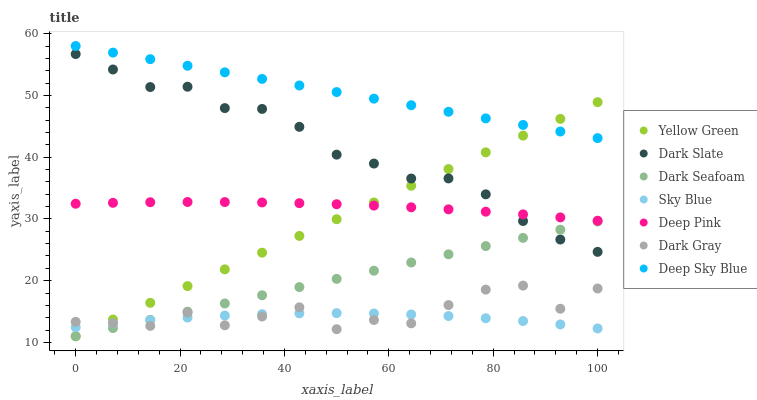Does Sky Blue have the minimum area under the curve?
Answer yes or no. Yes. Does Deep Sky Blue have the maximum area under the curve?
Answer yes or no. Yes. Does Yellow Green have the minimum area under the curve?
Answer yes or no. No. Does Yellow Green have the maximum area under the curve?
Answer yes or no. No. Is Dark Seafoam the smoothest?
Answer yes or no. Yes. Is Dark Gray the roughest?
Answer yes or no. Yes. Is Yellow Green the smoothest?
Answer yes or no. No. Is Yellow Green the roughest?
Answer yes or no. No. Does Yellow Green have the lowest value?
Answer yes or no. Yes. Does Dark Gray have the lowest value?
Answer yes or no. No. Does Deep Sky Blue have the highest value?
Answer yes or no. Yes. Does Yellow Green have the highest value?
Answer yes or no. No. Is Sky Blue less than Deep Pink?
Answer yes or no. Yes. Is Deep Pink greater than Dark Seafoam?
Answer yes or no. Yes. Does Dark Seafoam intersect Sky Blue?
Answer yes or no. Yes. Is Dark Seafoam less than Sky Blue?
Answer yes or no. No. Is Dark Seafoam greater than Sky Blue?
Answer yes or no. No. Does Sky Blue intersect Deep Pink?
Answer yes or no. No. 